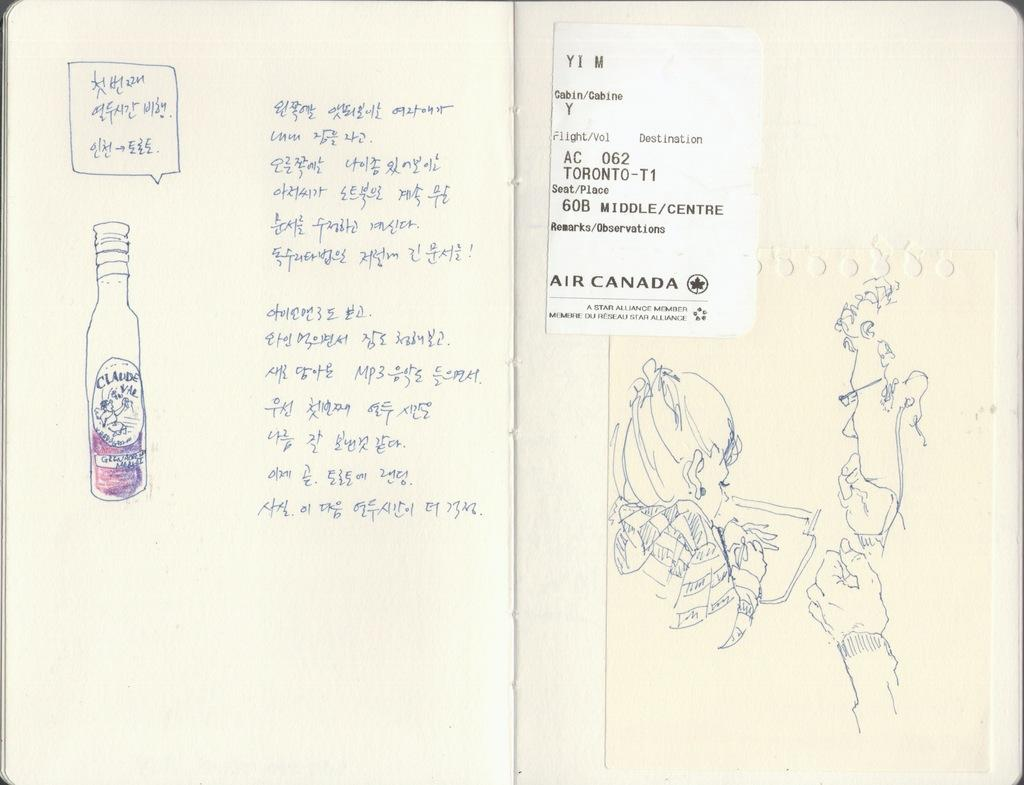<image>
Give a short and clear explanation of the subsequent image. A journal with images and words in Asian script has an Air Canada ticket stub between the pages. 